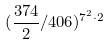Convert formula to latex. <formula><loc_0><loc_0><loc_500><loc_500>( \frac { 3 7 4 } { 2 } / 4 0 6 ) ^ { 7 ^ { 2 } \cdot 2 }</formula> 